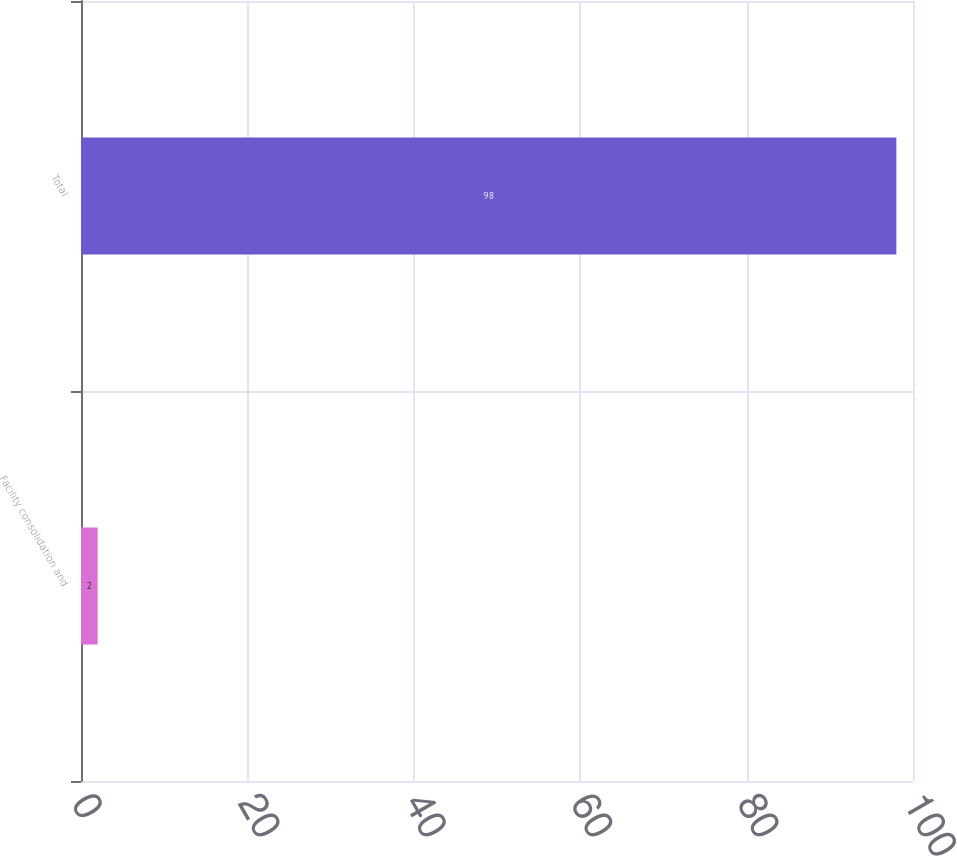<chart> <loc_0><loc_0><loc_500><loc_500><bar_chart><fcel>Facility consolidation and<fcel>Total<nl><fcel>2<fcel>98<nl></chart> 